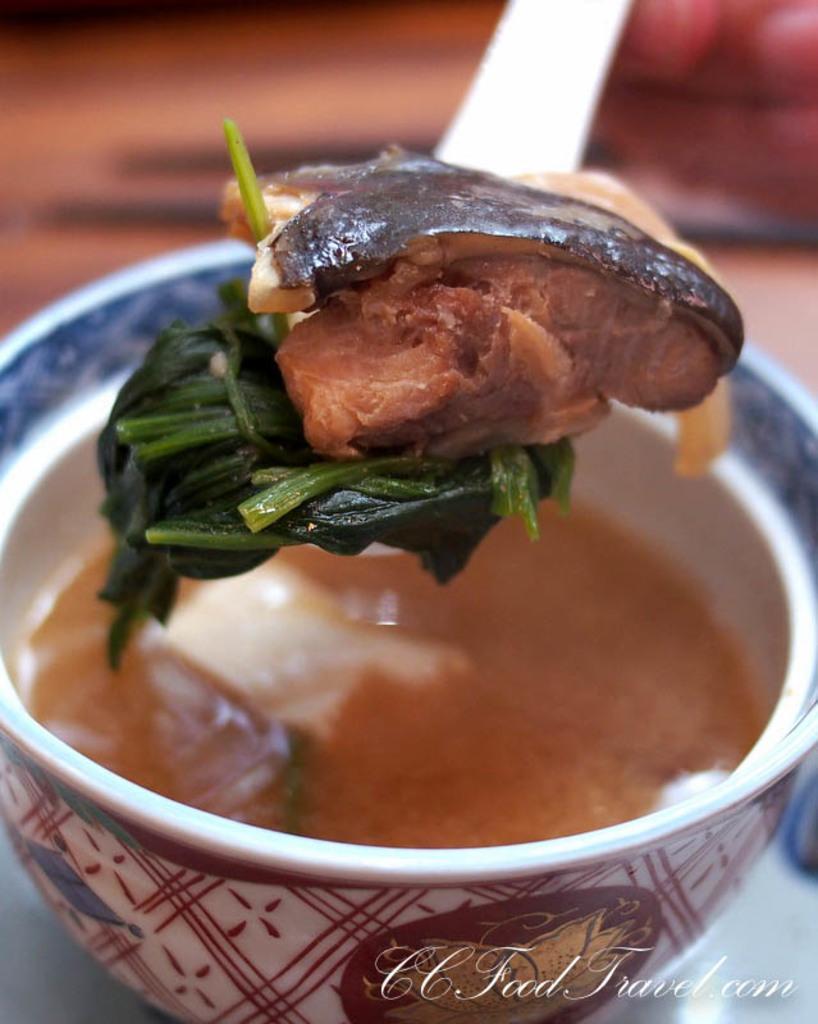Describe this image in one or two sentences. In this image there is a bowl in that bowl there is a food item and there is a spoon, on that spoon there is a food item, in the background it is blurred. 